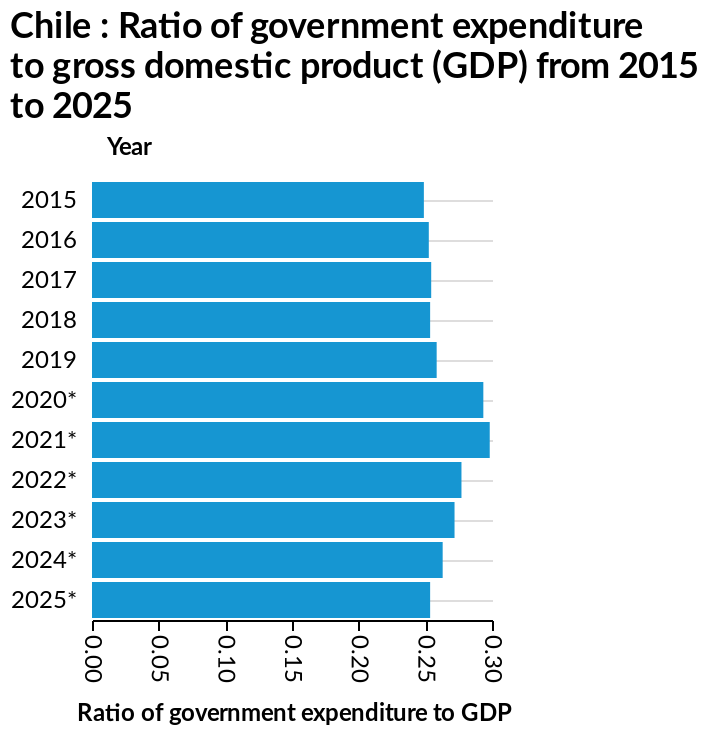<image>
Will the government expenditure to GDP continue to increase in 2021?  Yes, there will be a further increase in government expenditure to GDP in 2021. 